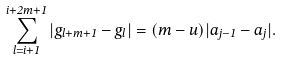Convert formula to latex. <formula><loc_0><loc_0><loc_500><loc_500>\sum _ { l = i + 1 } ^ { i + 2 m + 1 } | g _ { l + m + 1 } - g _ { l } | = ( m - u ) | a _ { j - 1 } - a _ { j } | .</formula> 